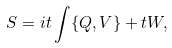Convert formula to latex. <formula><loc_0><loc_0><loc_500><loc_500>S & = i t \int \{ Q , V \} + t W ,</formula> 